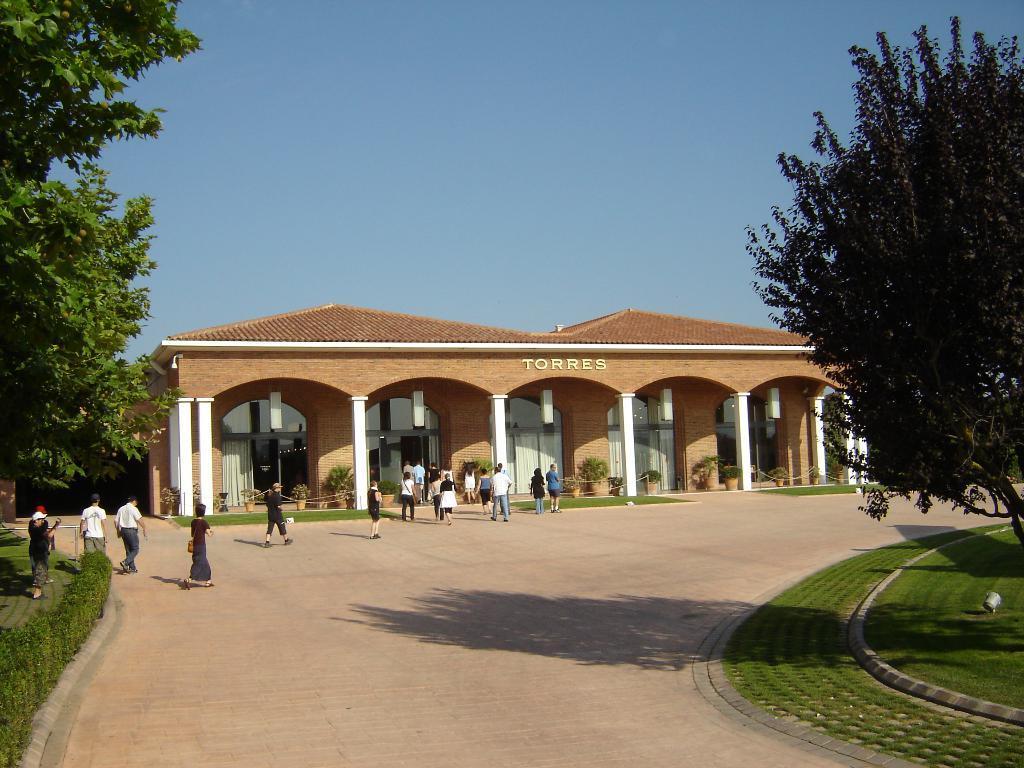Can you describe this image briefly? This is the picture of a place where we have a building to which there are some pillars, some things written and around there are some people, plants, trees and some grass on the floor. 